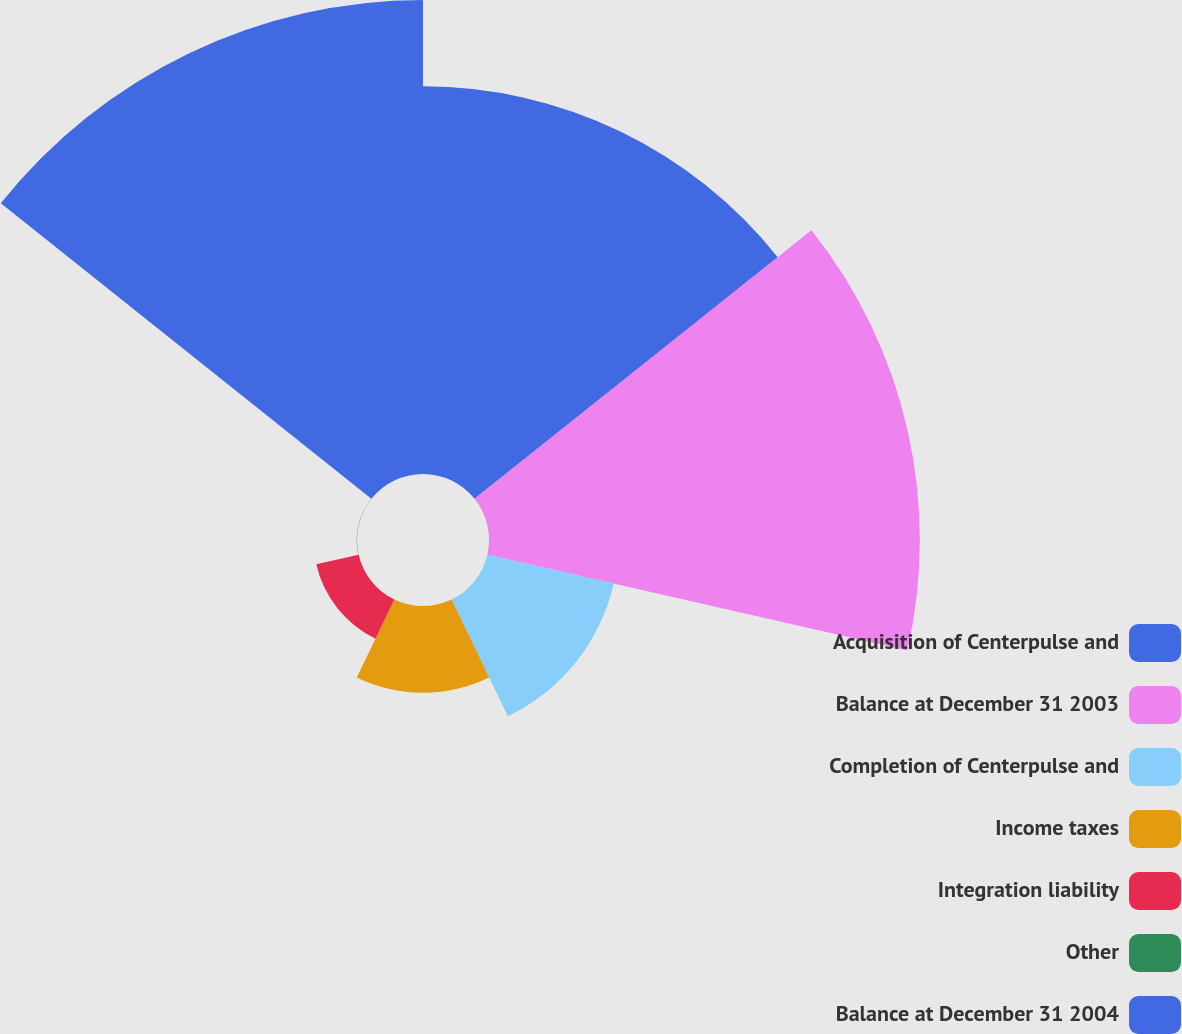Convert chart. <chart><loc_0><loc_0><loc_500><loc_500><pie_chart><fcel>Acquisition of Centerpulse and<fcel>Balance at December 31 2003<fcel>Completion of Centerpulse and<fcel>Income taxes<fcel>Integration liability<fcel>Other<fcel>Balance at December 31 2004<nl><fcel>24.97%<fcel>27.75%<fcel>8.35%<fcel>5.58%<fcel>2.8%<fcel>0.02%<fcel>30.53%<nl></chart> 